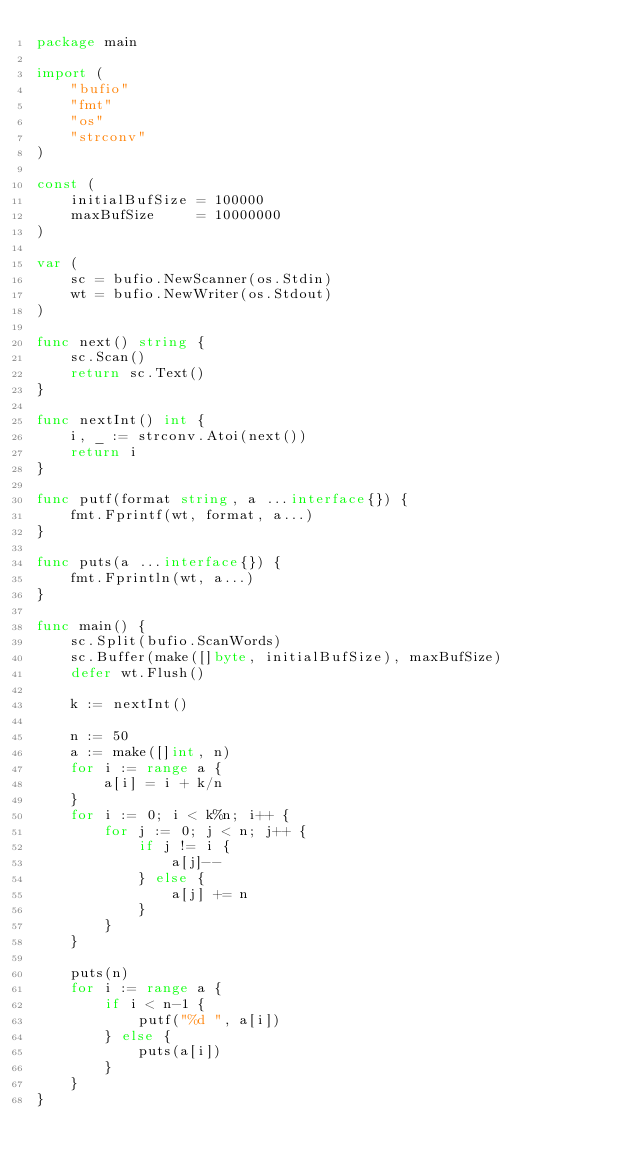Convert code to text. <code><loc_0><loc_0><loc_500><loc_500><_Go_>package main

import (
	"bufio"
	"fmt"
	"os"
	"strconv"
)

const (
	initialBufSize = 100000
	maxBufSize     = 10000000
)

var (
	sc = bufio.NewScanner(os.Stdin)
	wt = bufio.NewWriter(os.Stdout)
)

func next() string {
	sc.Scan()
	return sc.Text()
}

func nextInt() int {
	i, _ := strconv.Atoi(next())
	return i
}

func putf(format string, a ...interface{}) {
	fmt.Fprintf(wt, format, a...)
}

func puts(a ...interface{}) {
	fmt.Fprintln(wt, a...)
}

func main() {
	sc.Split(bufio.ScanWords)
	sc.Buffer(make([]byte, initialBufSize), maxBufSize)
	defer wt.Flush()

	k := nextInt()

	n := 50
	a := make([]int, n)
	for i := range a {
		a[i] = i + k/n
	}
	for i := 0; i < k%n; i++ {
		for j := 0; j < n; j++ {
			if j != i {
				a[j]--
			} else {
				a[j] += n
			}
		}
	}

	puts(n)
	for i := range a {
		if i < n-1 {
			putf("%d ", a[i])
		} else {
			puts(a[i])
		}
	}
}
</code> 